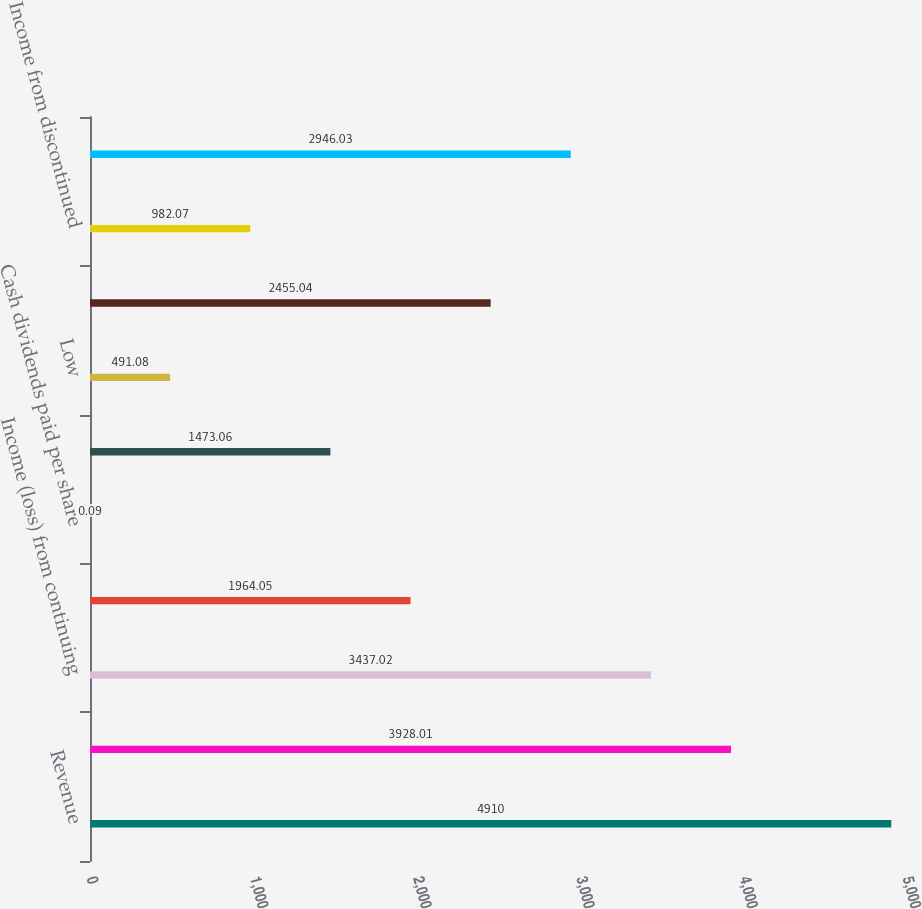Convert chart. <chart><loc_0><loc_0><loc_500><loc_500><bar_chart><fcel>Revenue<fcel>Operating income<fcel>Income (loss) from continuing<fcel>Net income (loss)<fcel>Cash dividends paid per share<fcel>High<fcel>Low<fcel>Income from continuing<fcel>Income from discontinued<fcel>Net income<nl><fcel>4910<fcel>3928.01<fcel>3437.02<fcel>1964.05<fcel>0.09<fcel>1473.06<fcel>491.08<fcel>2455.04<fcel>982.07<fcel>2946.03<nl></chart> 